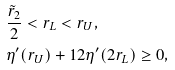<formula> <loc_0><loc_0><loc_500><loc_500>& \frac { \tilde { r } _ { 2 } } 2 < r _ { L } < r _ { U } , \\ & \eta ^ { \prime } ( r _ { U } ) + 1 2 \eta ^ { \prime } ( 2 r _ { L } ) \geq 0 ,</formula> 